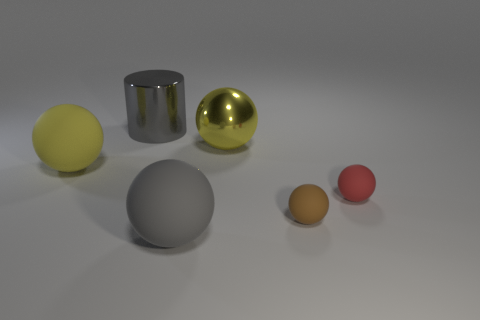What materials do the objects in the image seem to be made of? The objects in the image seem to be rendered with materials that simulate different textures: the largest ball has a reflective metallic surface, possibly indicating a material like steel or aluminum; the second largest ball appears to have a matte, rubber-like surface; the small ball and the cylinder in the center have surfaces that suggest a smooth, glossy plastic; and the two smallest spheres on the right have dull, non-reflective surfaces that could be interpreted as clay or a matte plastic. 